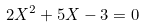<formula> <loc_0><loc_0><loc_500><loc_500>2 X ^ { 2 } + 5 X - 3 = 0</formula> 